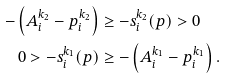Convert formula to latex. <formula><loc_0><loc_0><loc_500><loc_500>- \left ( A _ { i } ^ { k _ { 2 } } - p _ { i } ^ { k _ { 2 } } \right ) & \geq - s ^ { k _ { 2 } } _ { i } ( p ) > 0 \\ 0 > - s ^ { k _ { 1 } } _ { i } ( p ) & \geq - \left ( A _ { i } ^ { k _ { 1 } } - p _ { i } ^ { k _ { 1 } } \right ) .</formula> 